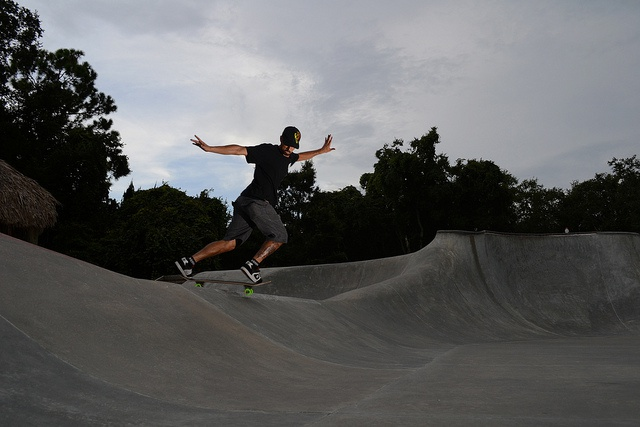Describe the objects in this image and their specific colors. I can see people in black, maroon, brown, and gray tones and skateboard in black, gray, and darkgreen tones in this image. 